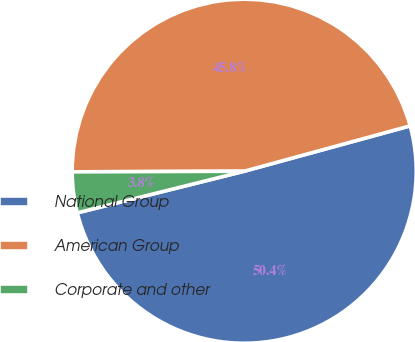<chart> <loc_0><loc_0><loc_500><loc_500><pie_chart><fcel>National Group<fcel>American Group<fcel>Corporate and other<nl><fcel>50.36%<fcel>45.81%<fcel>3.83%<nl></chart> 